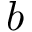Convert formula to latex. <formula><loc_0><loc_0><loc_500><loc_500>\ u _ { b }</formula> 